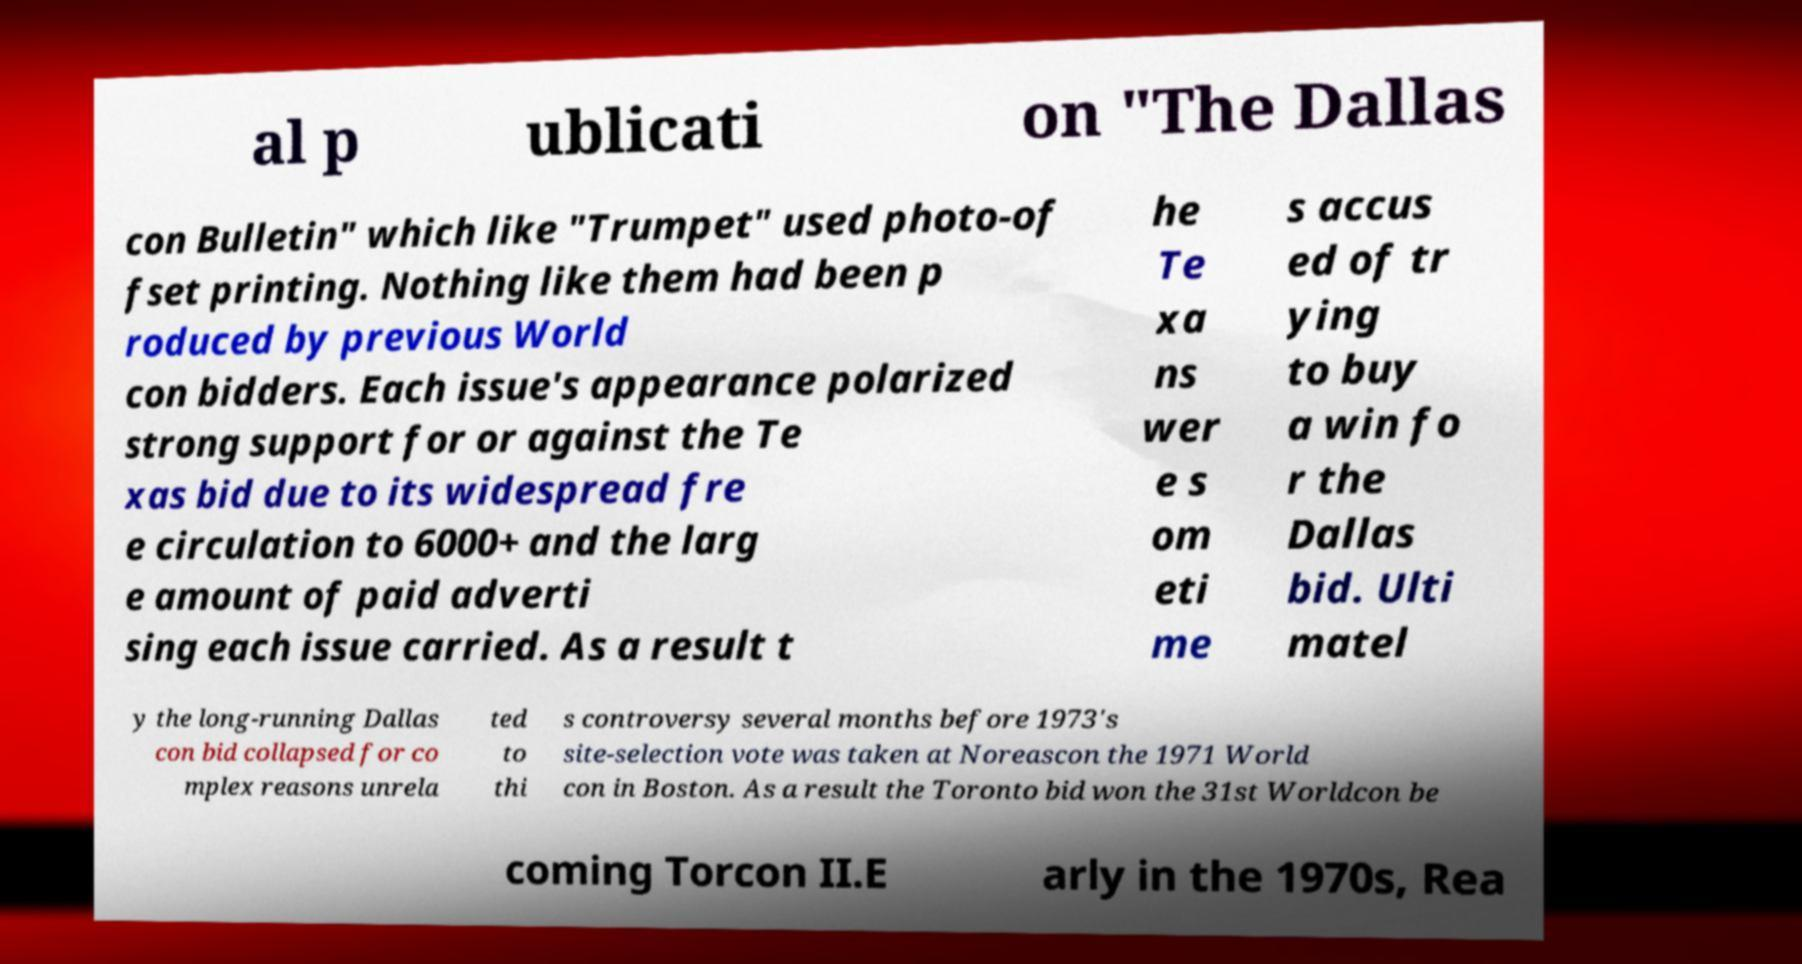I need the written content from this picture converted into text. Can you do that? al p ublicati on "The Dallas con Bulletin" which like "Trumpet" used photo-of fset printing. Nothing like them had been p roduced by previous World con bidders. Each issue's appearance polarized strong support for or against the Te xas bid due to its widespread fre e circulation to 6000+ and the larg e amount of paid adverti sing each issue carried. As a result t he Te xa ns wer e s om eti me s accus ed of tr ying to buy a win fo r the Dallas bid. Ulti matel y the long-running Dallas con bid collapsed for co mplex reasons unrela ted to thi s controversy several months before 1973's site-selection vote was taken at Noreascon the 1971 World con in Boston. As a result the Toronto bid won the 31st Worldcon be coming Torcon II.E arly in the 1970s, Rea 